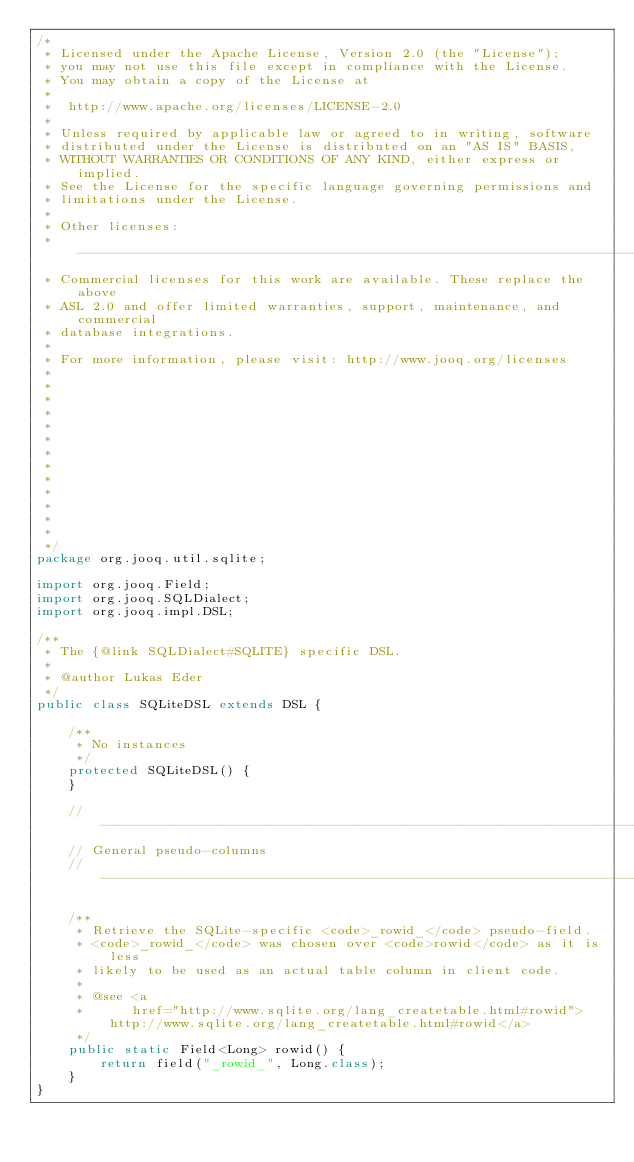<code> <loc_0><loc_0><loc_500><loc_500><_Java_>/*
 * Licensed under the Apache License, Version 2.0 (the "License");
 * you may not use this file except in compliance with the License.
 * You may obtain a copy of the License at
 *
 *  http://www.apache.org/licenses/LICENSE-2.0
 *
 * Unless required by applicable law or agreed to in writing, software
 * distributed under the License is distributed on an "AS IS" BASIS,
 * WITHOUT WARRANTIES OR CONDITIONS OF ANY KIND, either express or implied.
 * See the License for the specific language governing permissions and
 * limitations under the License.
 *
 * Other licenses:
 * -----------------------------------------------------------------------------
 * Commercial licenses for this work are available. These replace the above
 * ASL 2.0 and offer limited warranties, support, maintenance, and commercial
 * database integrations.
 *
 * For more information, please visit: http://www.jooq.org/licenses
 *
 *
 *
 *
 *
 *
 *
 *
 *
 *
 *
 *
 *
 */
package org.jooq.util.sqlite;

import org.jooq.Field;
import org.jooq.SQLDialect;
import org.jooq.impl.DSL;

/**
 * The {@link SQLDialect#SQLITE} specific DSL.
 *
 * @author Lukas Eder
 */
public class SQLiteDSL extends DSL {

    /**
     * No instances
     */
    protected SQLiteDSL() {
    }

    // -------------------------------------------------------------------------
    // General pseudo-columns
    // -------------------------------------------------------------------------

    /**
     * Retrieve the SQLite-specific <code>_rowid_</code> pseudo-field.
     * <code>_rowid_</code> was chosen over <code>rowid</code> as it is less
     * likely to be used as an actual table column in client code.
     *
     * @see <a
     *      href="http://www.sqlite.org/lang_createtable.html#rowid">http://www.sqlite.org/lang_createtable.html#rowid</a>
     */
    public static Field<Long> rowid() {
        return field("_rowid_", Long.class);
    }
}
</code> 